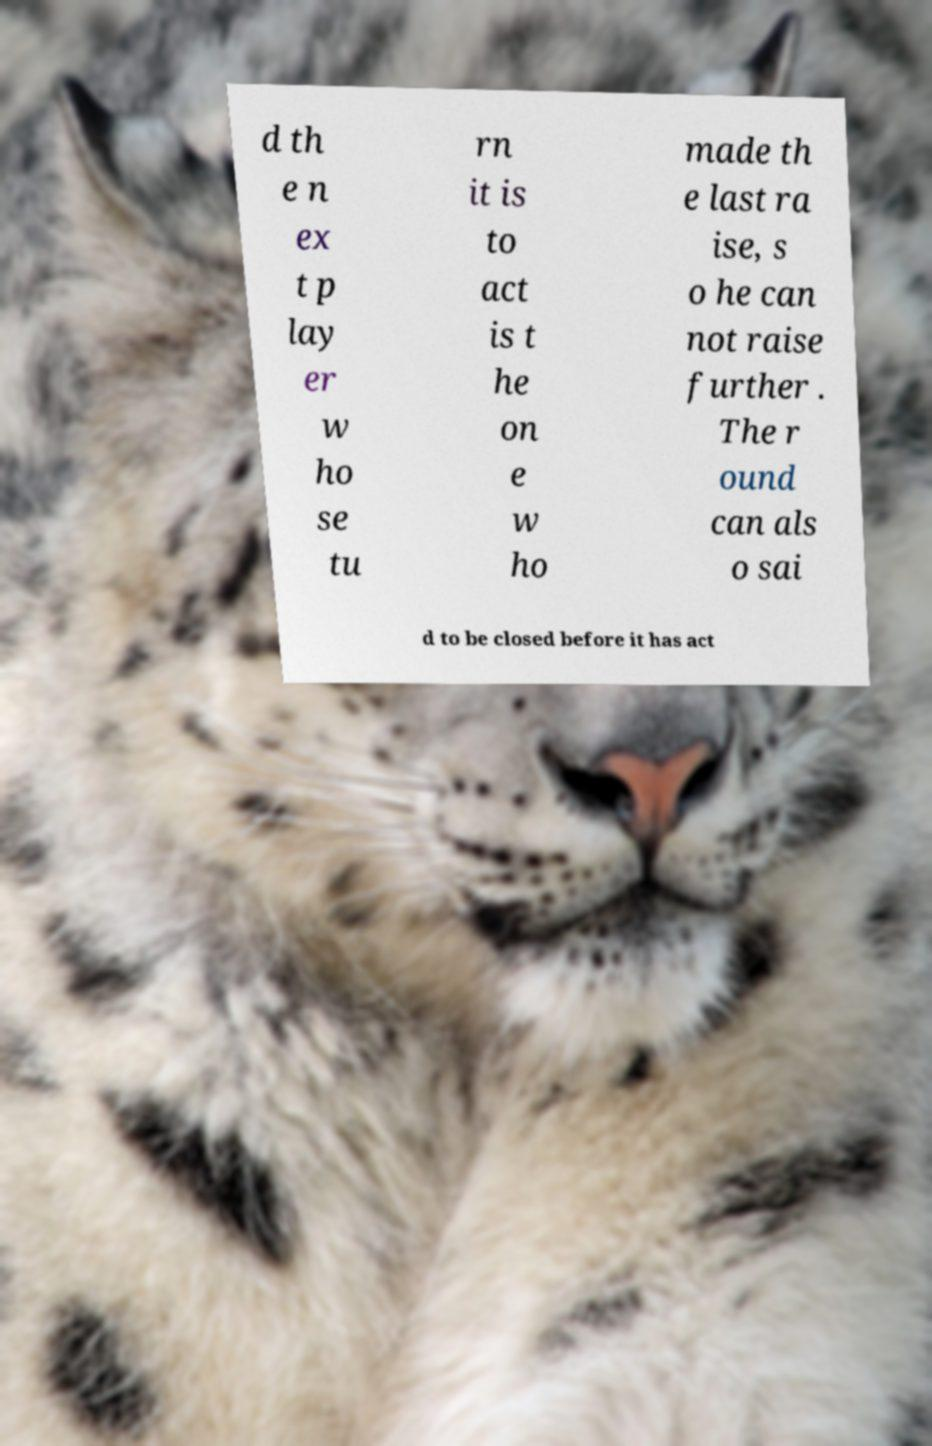Could you extract and type out the text from this image? d th e n ex t p lay er w ho se tu rn it is to act is t he on e w ho made th e last ra ise, s o he can not raise further . The r ound can als o sai d to be closed before it has act 